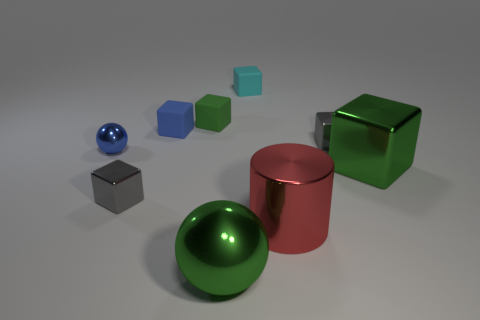How many gray blocks must be subtracted to get 1 gray blocks? 1 Subtract all small cyan blocks. How many blocks are left? 5 Subtract all blue cubes. How many cubes are left? 5 Subtract all blue cubes. Subtract all brown balls. How many cubes are left? 5 Subtract all cylinders. How many objects are left? 8 Subtract 0 blue cylinders. How many objects are left? 9 Subtract all shiny cylinders. Subtract all tiny gray objects. How many objects are left? 6 Add 5 tiny blue rubber blocks. How many tiny blue rubber blocks are left? 6 Add 5 gray metallic spheres. How many gray metallic spheres exist? 5 